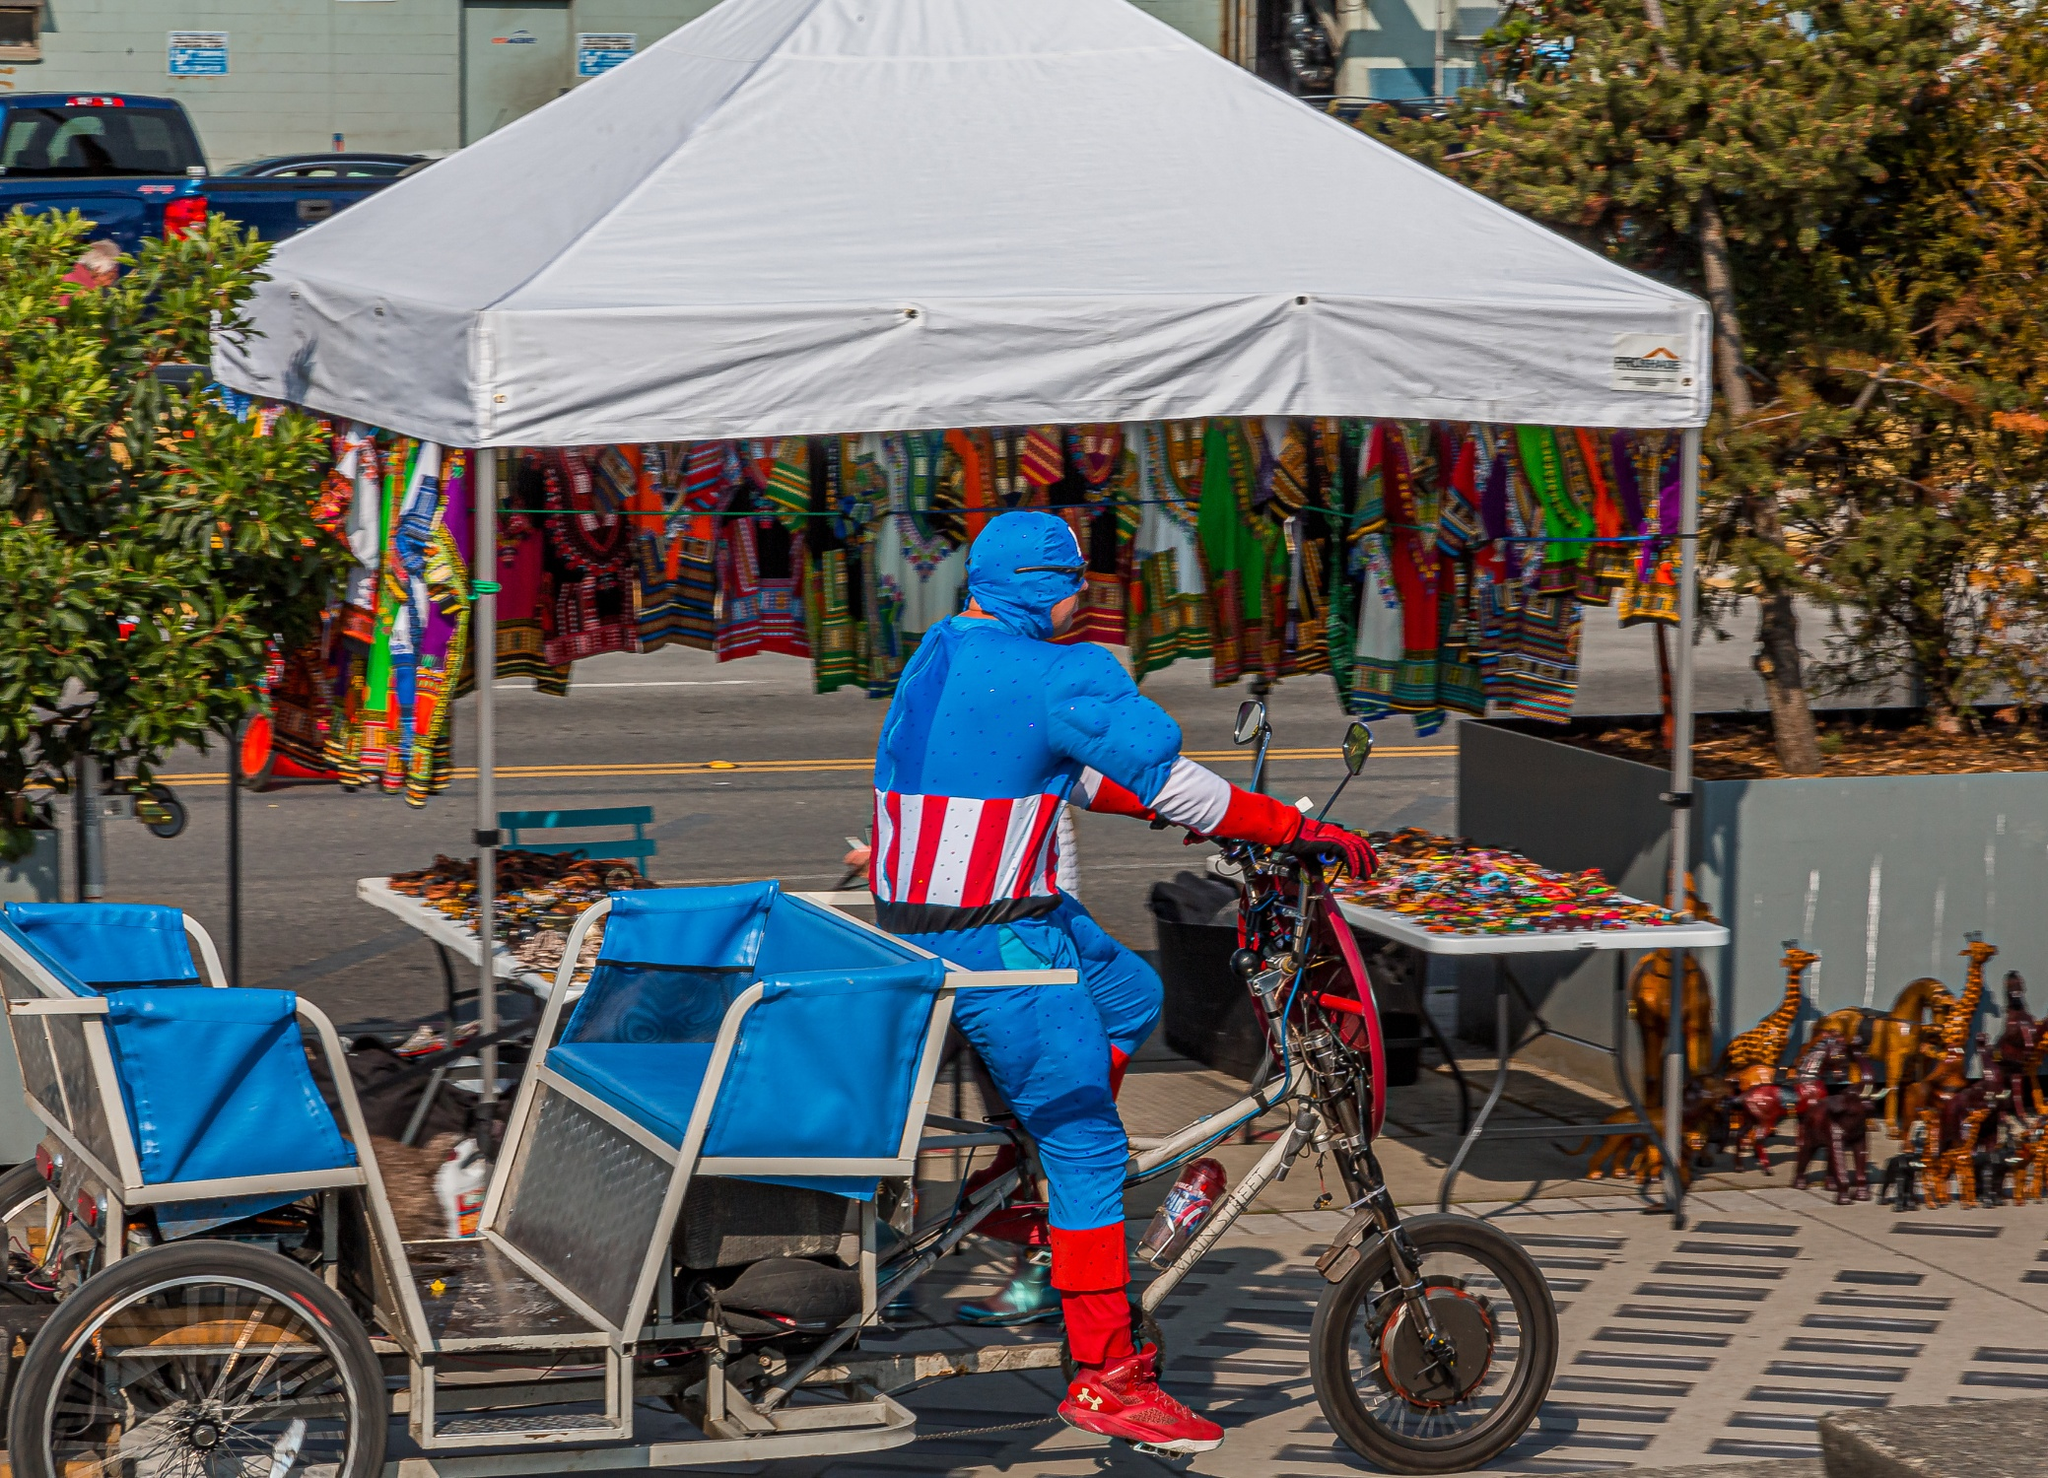What kinds of items are being sold in the background, and how does their presence enhance the overall atmosphere of the scene? The background features a variety of vibrant, culturally rich items for sale, including colorful clothing, accessories, and possibly local handicrafts under a white tent. Their presence enhances the festive, vibrant atmosphere of the scene, adding a sense of community and cultural diversity. It suggests the area might be a popular spot for both locals and tourists to explore and shop, bringing together different aspects of urban and cultural life, which complements the playful, superhero-themed forefront. 